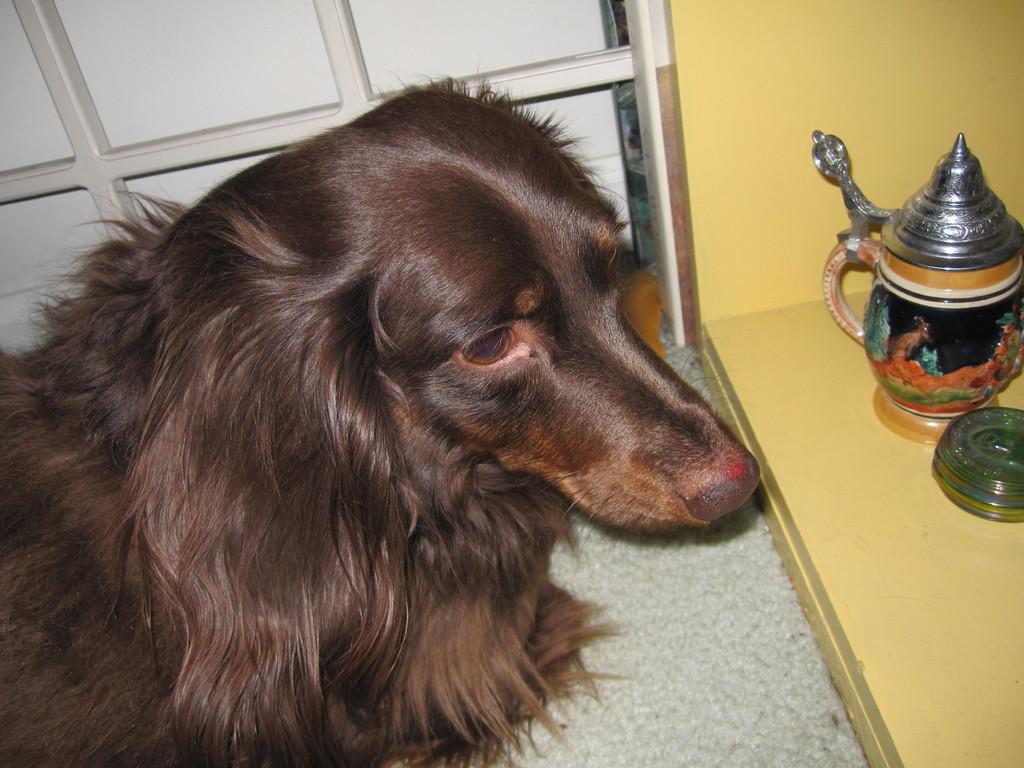What animal is located on the left side of the image? There is a dog on the left side of the image. In which direction is the dog facing? The dog is facing towards the right side. What can be seen on the right side of the image? There is a jar on a wooden plank on the right side of the image. What type of structure is present at the top of the image? There is a metal frame at the top of the image. What type of whip is the farmer using to control the dog in the image? There is no farmer or whip present in the image; it features a dog and a jar on a wooden plank. 